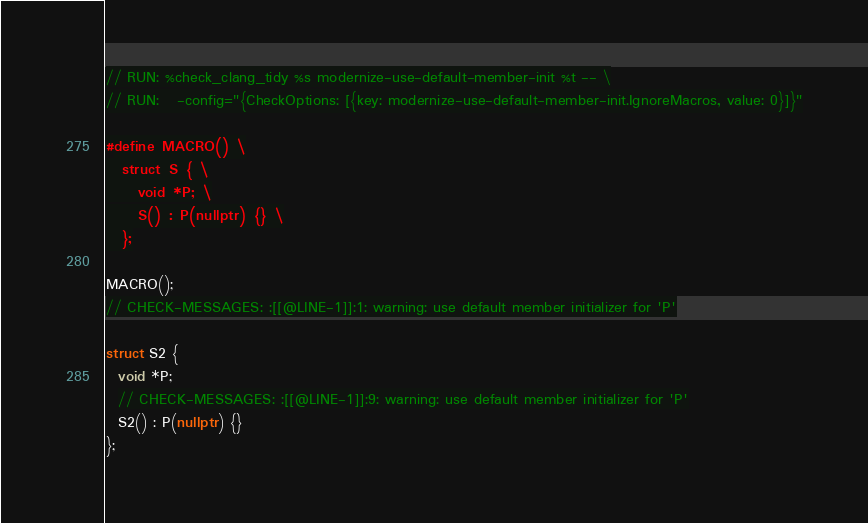Convert code to text. <code><loc_0><loc_0><loc_500><loc_500><_C++_>// RUN: %check_clang_tidy %s modernize-use-default-member-init %t -- \
// RUN:   -config="{CheckOptions: [{key: modernize-use-default-member-init.IgnoreMacros, value: 0}]}"

#define MACRO() \
  struct S { \
    void *P; \
    S() : P(nullptr) {} \
  };

MACRO();
// CHECK-MESSAGES: :[[@LINE-1]]:1: warning: use default member initializer for 'P'

struct S2 {
  void *P;
  // CHECK-MESSAGES: :[[@LINE-1]]:9: warning: use default member initializer for 'P'
  S2() : P(nullptr) {}
};
</code> 